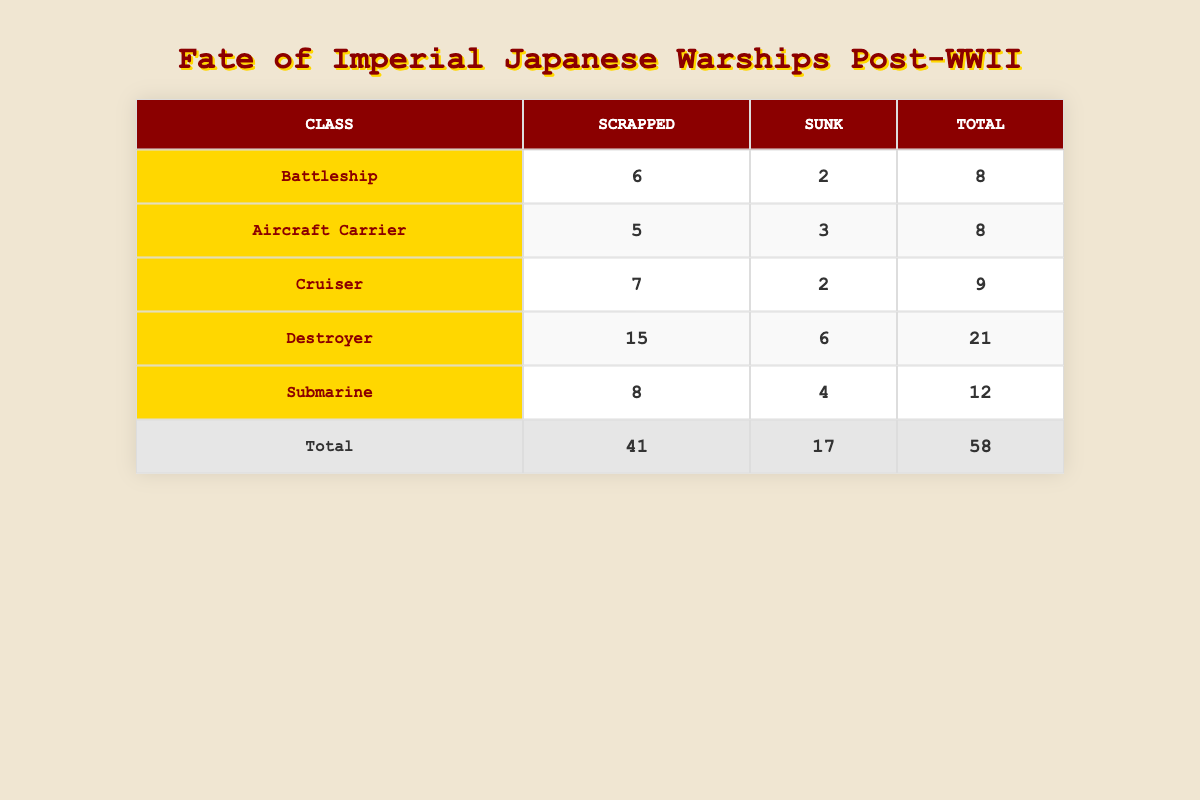What is the total number of Destroyers in the table? The table shows that there are 15 Destroyers that were scrapped and 6 that were sunk. Adding these together gives 15 + 6 = 21.
Answer: 21 How many Battleships were either scrapped or sunk? The table lists 6 Battleships that were scrapped and 2 that were sunk. Adding these amounts together yields 6 + 2 = 8.
Answer: 8 Did more Aircraft Carriers get sunk than scrapped? The table indicates that 5 Aircraft Carriers were scrapped and 3 were sunk. Since 3 is less than 5, the answer is no.
Answer: No What percentage of Cruisers were sunk? The table indicates that 2 Cruisers were sunk out of a total of 9 Cruisers (7 scrapped + 2 sunk). To find the percentage, divide 2 by 9 and multiply by 100, which gives (2/9) * 100 ≈ 22.22%.
Answer: Approximately 22.22% Which class had the highest number of total warships accounted for in the table? The table shows the total numbers for each class: Battleships (8), Aircraft Carriers (8), Cruisers (9), Destroyers (21), and Submarines (12). The highest number is 21 for Destroyers.
Answer: Destroyer How many more Destroyers were scrapped than Cruisers? According to the table, 15 Destroyers were scrapped and 7 Cruisers were scrapped. The difference is 15 - 7 = 8.
Answer: 8 What is the total number of vessels listed in the table? By summing the total number of vessels for each category: 8 (Battleships) + 8 (Aircraft Carriers) + 9 (Cruisers) + 21 (Destroyers) + 12 (Submarines), we get a total of 58 vessels.
Answer: 58 Are there more vessels scrapped than sunk overall? The total number scrapped is 41 (from summing scrapped values: 6 + 5 + 7 + 15 + 8) and the total sunk is 17 (from summing sunk values: 2 + 3 + 2 + 6 + 4). Since 41 is greater than 17, the answer is yes.
Answer: Yes 